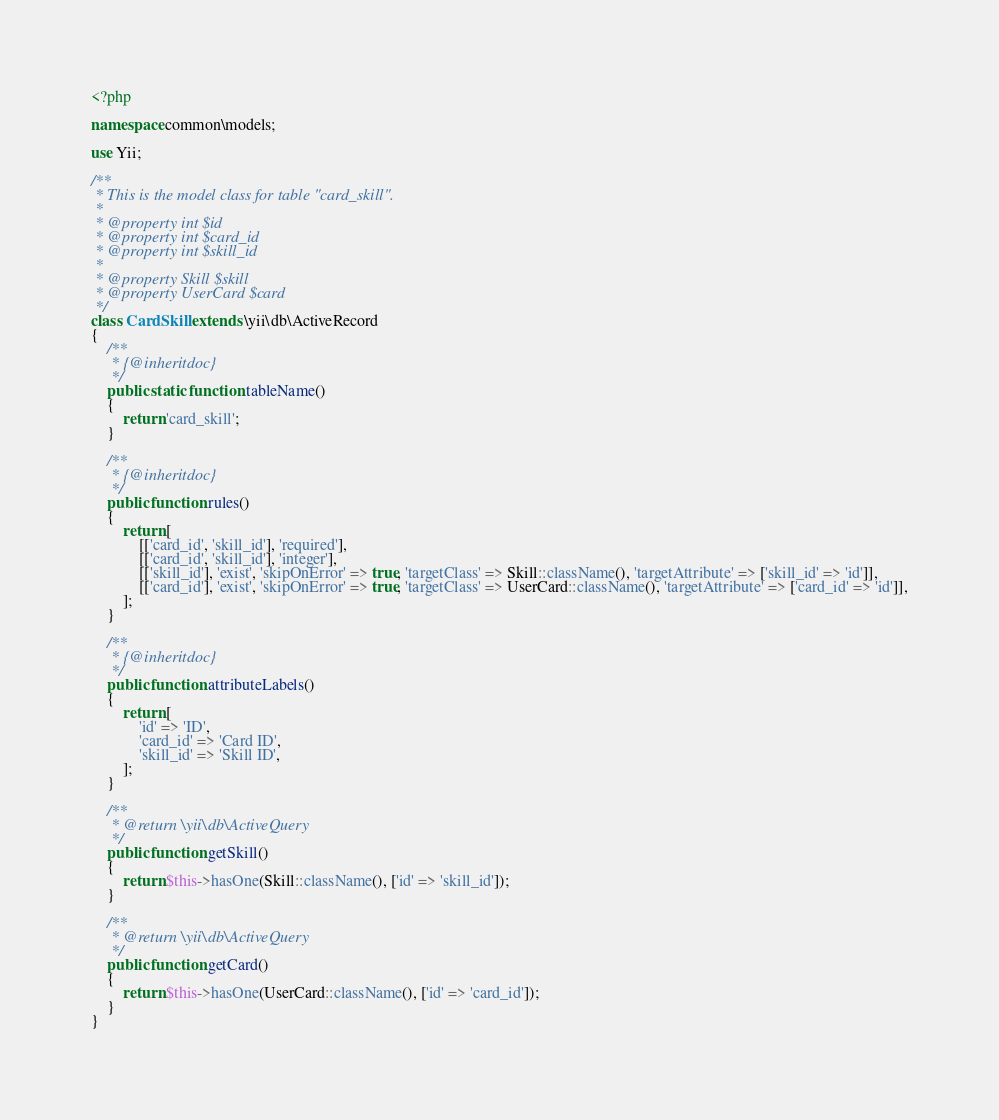Convert code to text. <code><loc_0><loc_0><loc_500><loc_500><_PHP_><?php

namespace common\models;

use Yii;

/**
 * This is the model class for table "card_skill".
 *
 * @property int $id
 * @property int $card_id
 * @property int $skill_id
 *
 * @property Skill $skill
 * @property UserCard $card
 */
class CardSkill extends \yii\db\ActiveRecord
{
    /**
     * {@inheritdoc}
     */
    public static function tableName()
    {
        return 'card_skill';
    }

    /**
     * {@inheritdoc}
     */
    public function rules()
    {
        return [
            [['card_id', 'skill_id'], 'required'],
            [['card_id', 'skill_id'], 'integer'],
            [['skill_id'], 'exist', 'skipOnError' => true, 'targetClass' => Skill::className(), 'targetAttribute' => ['skill_id' => 'id']],
            [['card_id'], 'exist', 'skipOnError' => true, 'targetClass' => UserCard::className(), 'targetAttribute' => ['card_id' => 'id']],
        ];
    }

    /**
     * {@inheritdoc}
     */
    public function attributeLabels()
    {
        return [
            'id' => 'ID',
            'card_id' => 'Card ID',
            'skill_id' => 'Skill ID',
        ];
    }

    /**
     * @return \yii\db\ActiveQuery
     */
    public function getSkill()
    {
        return $this->hasOne(Skill::className(), ['id' => 'skill_id']);
    }

    /**
     * @return \yii\db\ActiveQuery
     */
    public function getCard()
    {
        return $this->hasOne(UserCard::className(), ['id' => 'card_id']);
    }
}
</code> 